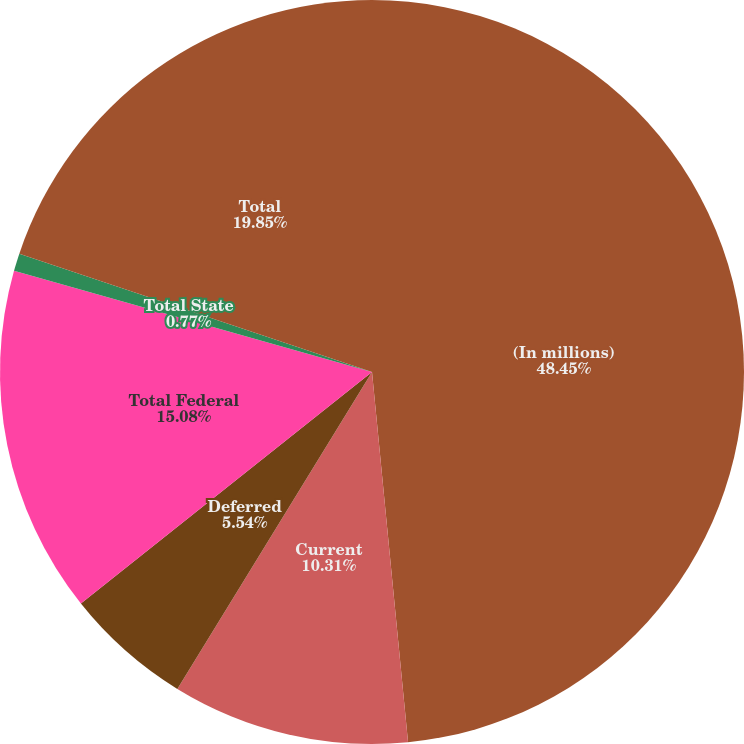<chart> <loc_0><loc_0><loc_500><loc_500><pie_chart><fcel>(In millions)<fcel>Current<fcel>Deferred<fcel>Total Federal<fcel>Total State<fcel>Total<nl><fcel>48.46%<fcel>10.31%<fcel>5.54%<fcel>15.08%<fcel>0.77%<fcel>19.85%<nl></chart> 